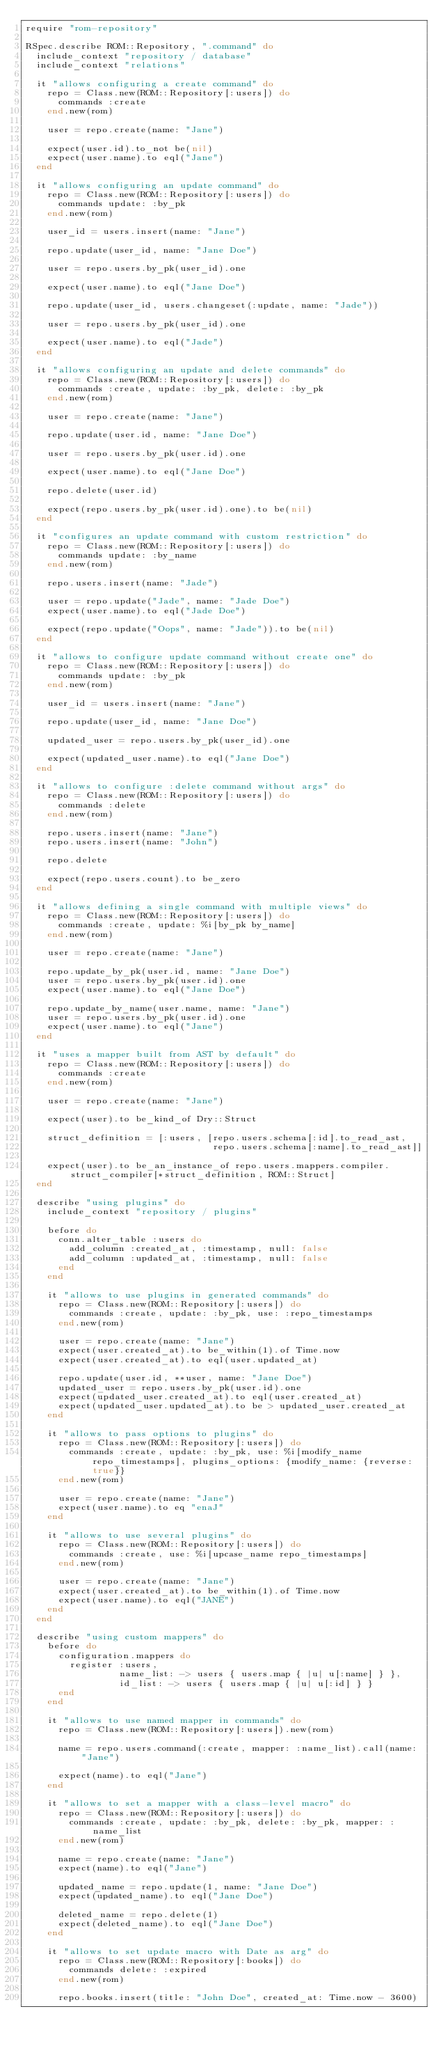<code> <loc_0><loc_0><loc_500><loc_500><_Ruby_>require "rom-repository"

RSpec.describe ROM::Repository, ".command" do
  include_context "repository / database"
  include_context "relations"

  it "allows configuring a create command" do
    repo = Class.new(ROM::Repository[:users]) do
      commands :create
    end.new(rom)

    user = repo.create(name: "Jane")

    expect(user.id).to_not be(nil)
    expect(user.name).to eql("Jane")
  end

  it "allows configuring an update command" do
    repo = Class.new(ROM::Repository[:users]) do
      commands update: :by_pk
    end.new(rom)

    user_id = users.insert(name: "Jane")

    repo.update(user_id, name: "Jane Doe")

    user = repo.users.by_pk(user_id).one

    expect(user.name).to eql("Jane Doe")

    repo.update(user_id, users.changeset(:update, name: "Jade"))

    user = repo.users.by_pk(user_id).one

    expect(user.name).to eql("Jade")
  end

  it "allows configuring an update and delete commands" do
    repo = Class.new(ROM::Repository[:users]) do
      commands :create, update: :by_pk, delete: :by_pk
    end.new(rom)

    user = repo.create(name: "Jane")

    repo.update(user.id, name: "Jane Doe")

    user = repo.users.by_pk(user.id).one

    expect(user.name).to eql("Jane Doe")

    repo.delete(user.id)

    expect(repo.users.by_pk(user.id).one).to be(nil)
  end

  it "configures an update command with custom restriction" do
    repo = Class.new(ROM::Repository[:users]) do
      commands update: :by_name
    end.new(rom)

    repo.users.insert(name: "Jade")

    user = repo.update("Jade", name: "Jade Doe")
    expect(user.name).to eql("Jade Doe")

    expect(repo.update("Oops", name: "Jade")).to be(nil)
  end

  it "allows to configure update command without create one" do
    repo = Class.new(ROM::Repository[:users]) do
      commands update: :by_pk
    end.new(rom)

    user_id = users.insert(name: "Jane")

    repo.update(user_id, name: "Jane Doe")

    updated_user = repo.users.by_pk(user_id).one

    expect(updated_user.name).to eql("Jane Doe")
  end

  it "allows to configure :delete command without args" do
    repo = Class.new(ROM::Repository[:users]) do
      commands :delete
    end.new(rom)

    repo.users.insert(name: "Jane")
    repo.users.insert(name: "John")

    repo.delete

    expect(repo.users.count).to be_zero
  end

  it "allows defining a single command with multiple views" do
    repo = Class.new(ROM::Repository[:users]) do
      commands :create, update: %i[by_pk by_name]
    end.new(rom)

    user = repo.create(name: "Jane")

    repo.update_by_pk(user.id, name: "Jane Doe")
    user = repo.users.by_pk(user.id).one
    expect(user.name).to eql("Jane Doe")

    repo.update_by_name(user.name, name: "Jane")
    user = repo.users.by_pk(user.id).one
    expect(user.name).to eql("Jane")
  end

  it "uses a mapper built from AST by default" do
    repo = Class.new(ROM::Repository[:users]) do
      commands :create
    end.new(rom)

    user = repo.create(name: "Jane")

    expect(user).to be_kind_of Dry::Struct

    struct_definition = [:users, [repo.users.schema[:id].to_read_ast,
                                  repo.users.schema[:name].to_read_ast]]

    expect(user).to be_an_instance_of repo.users.mappers.compiler.struct_compiler[*struct_definition, ROM::Struct]
  end

  describe "using plugins" do
    include_context "repository / plugins"

    before do
      conn.alter_table :users do
        add_column :created_at, :timestamp, null: false
        add_column :updated_at, :timestamp, null: false
      end
    end

    it "allows to use plugins in generated commands" do
      repo = Class.new(ROM::Repository[:users]) do
        commands :create, update: :by_pk, use: :repo_timestamps
      end.new(rom)

      user = repo.create(name: "Jane")
      expect(user.created_at).to be_within(1).of Time.now
      expect(user.created_at).to eql(user.updated_at)

      repo.update(user.id, **user, name: "Jane Doe")
      updated_user = repo.users.by_pk(user.id).one
      expect(updated_user.created_at).to eql(user.created_at)
      expect(updated_user.updated_at).to be > updated_user.created_at
    end

    it "allows to pass options to plugins" do
      repo = Class.new(ROM::Repository[:users]) do
        commands :create, update: :by_pk, use: %i[modify_name repo_timestamps], plugins_options: {modify_name: {reverse: true}}
      end.new(rom)

      user = repo.create(name: "Jane")
      expect(user.name).to eq "enaJ"
    end

    it "allows to use several plugins" do
      repo = Class.new(ROM::Repository[:users]) do
        commands :create, use: %i[upcase_name repo_timestamps]
      end.new(rom)

      user = repo.create(name: "Jane")
      expect(user.created_at).to be_within(1).of Time.now
      expect(user.name).to eql("JANE")
    end
  end

  describe "using custom mappers" do
    before do
      configuration.mappers do
        register :users,
                 name_list: -> users { users.map { |u| u[:name] } },
                 id_list: -> users { users.map { |u| u[:id] } }
      end
    end

    it "allows to use named mapper in commands" do
      repo = Class.new(ROM::Repository[:users]).new(rom)

      name = repo.users.command(:create, mapper: :name_list).call(name: "Jane")

      expect(name).to eql("Jane")
    end

    it "allows to set a mapper with a class-level macro" do
      repo = Class.new(ROM::Repository[:users]) do
        commands :create, update: :by_pk, delete: :by_pk, mapper: :name_list
      end.new(rom)

      name = repo.create(name: "Jane")
      expect(name).to eql("Jane")

      updated_name = repo.update(1, name: "Jane Doe")
      expect(updated_name).to eql("Jane Doe")

      deleted_name = repo.delete(1)
      expect(deleted_name).to eql("Jane Doe")
    end

    it "allows to set update macro with Date as arg" do
      repo = Class.new(ROM::Repository[:books]) do
        commands delete: :expired
      end.new(rom)

      repo.books.insert(title: "John Doe", created_at: Time.now - 3600)
</code> 